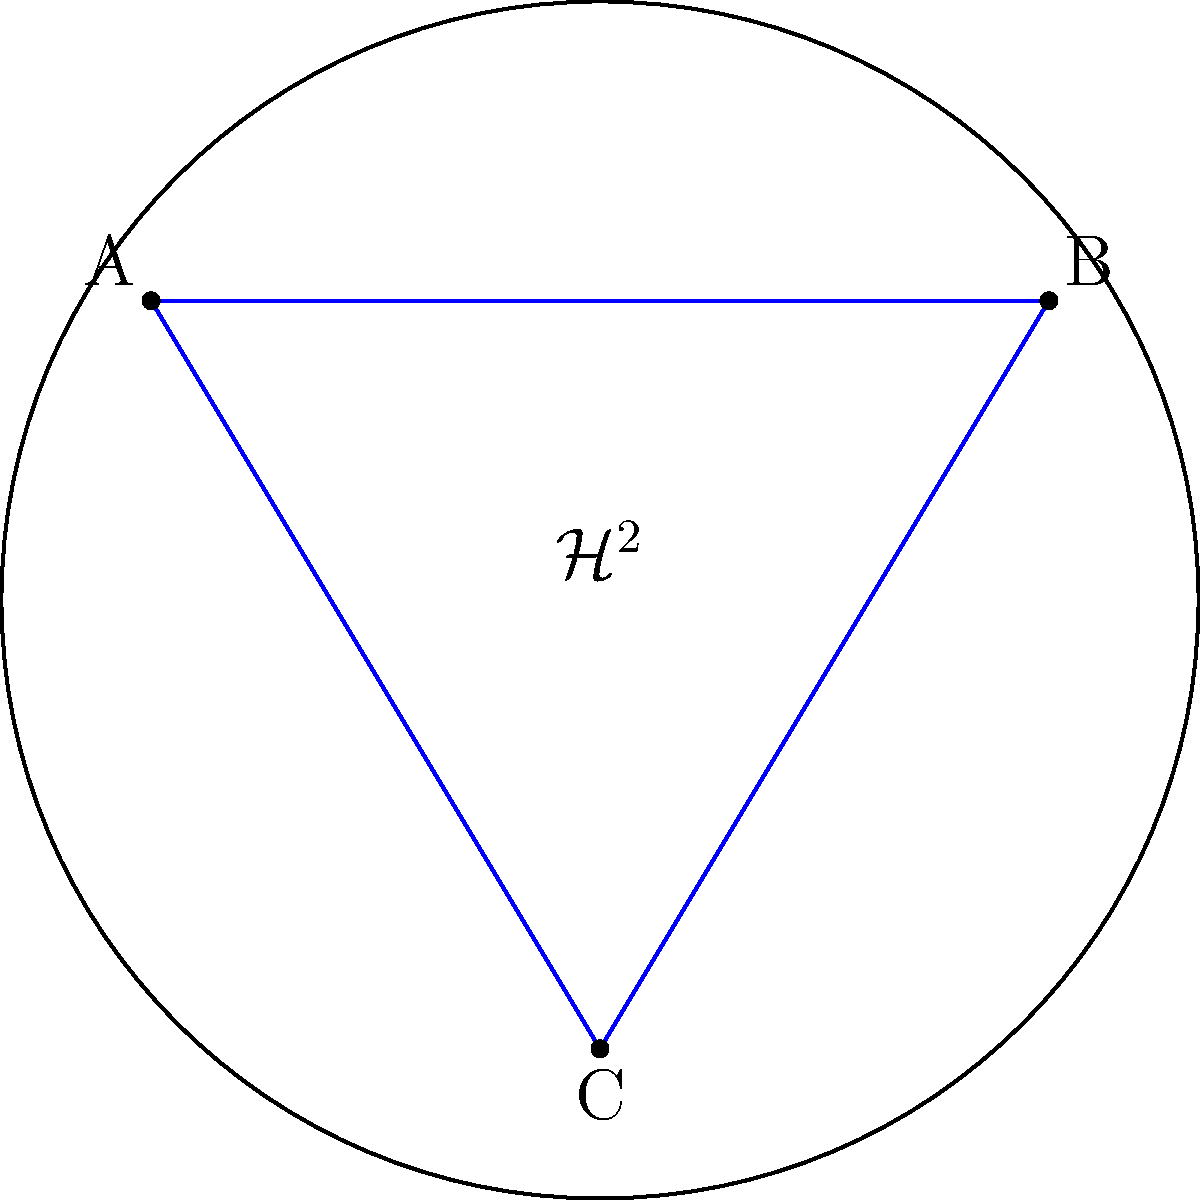In the hyperbolic plane model $\mathcal{H}^2$ shown above, triangle ABC is drawn. If the sum of the interior angles of this triangle is 150°, what is the area of this triangle in terms of $\pi$ and the radius of curvature $R$ of the hyperbolic plane? To solve this problem, we'll use the Gauss-Bonnet theorem for hyperbolic geometry. The steps are as follows:

1) In Euclidean geometry, the sum of interior angles of a triangle is always 180°. In hyperbolic geometry, this sum is always less than 180°.

2) The difference between 180° and the sum of the angles is called the defect, $\delta$. Here:
   $\delta = 180° - 150° = 30° = \frac{\pi}{6}$ radians

3) The Gauss-Bonnet theorem states that for a triangle in a hyperbolic plane with constant negative curvature $K = -\frac{1}{R^2}$, the area $A$ is given by:
   $A = (\pi - (\alpha + \beta + \gamma)) R^2 = \delta R^2$

   Where $\alpha$, $\beta$, and $\gamma$ are the interior angles of the triangle, and $R$ is the radius of curvature.

4) Substituting our known defect:
   $A = \frac{\pi}{6} R^2$

5) To express this in terms of $\pi$ and $R$:
   $A = \frac{\pi R^2}{6}$

This formula gives us the area of the hyperbolic triangle in terms of $\pi$ and the radius of curvature $R$.
Answer: $\frac{\pi R^2}{6}$ 